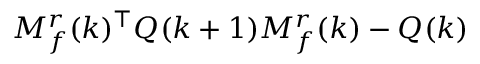Convert formula to latex. <formula><loc_0><loc_0><loc_500><loc_500>M _ { f } ^ { r } ( k ) ^ { \top } Q ( k + 1 ) M _ { f } ^ { r } ( k ) - Q ( k )</formula> 